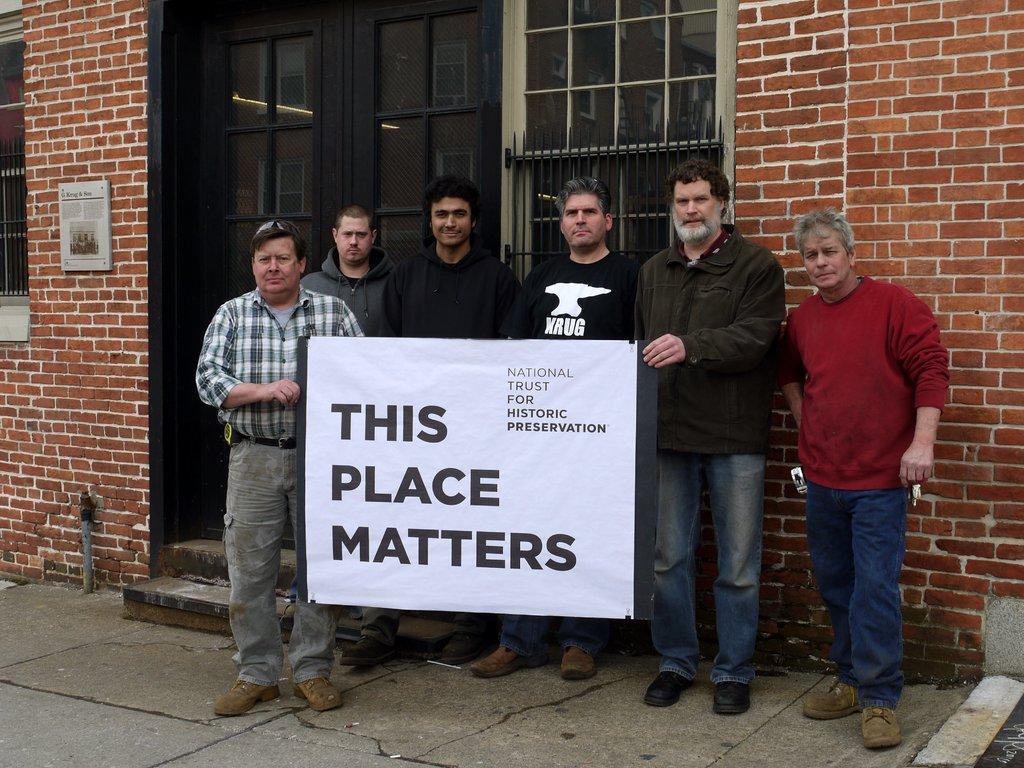In one or two sentences, can you explain what this image depicts? In this picture I can see few people are standing in the middle, they are holding the banner, in the background I can see the doors, windows and the walls. 